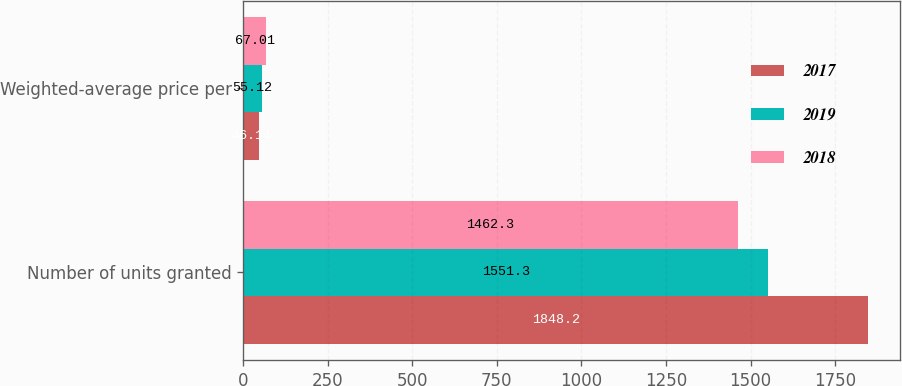<chart> <loc_0><loc_0><loc_500><loc_500><stacked_bar_chart><ecel><fcel>Number of units granted<fcel>Weighted-average price per<nl><fcel>2017<fcel>1848.2<fcel>46.14<nl><fcel>2019<fcel>1551.3<fcel>55.12<nl><fcel>2018<fcel>1462.3<fcel>67.01<nl></chart> 